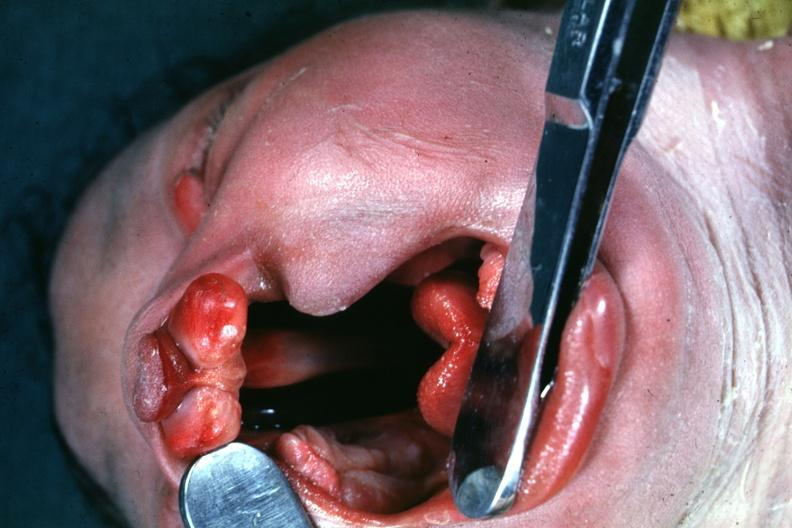s opened uterus and cervix with large cervical myoma protruding into vagina slide present?
Answer the question using a single word or phrase. No 